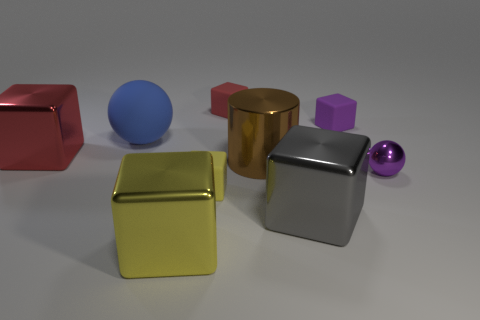What is the material of the small object that is on the left side of the purple cube and in front of the big brown cylinder?
Offer a very short reply. Rubber. What number of small objects are either gray blocks or blocks?
Your answer should be compact. 3. The purple metallic object has what size?
Give a very brief answer. Small. What is the shape of the small red object?
Your answer should be compact. Cube. Are there any other things that have the same shape as the brown thing?
Keep it short and to the point. No. Is the number of small purple matte cubes that are behind the red matte thing less than the number of big yellow shiny objects?
Offer a terse response. Yes. Do the tiny rubber thing that is to the right of the tiny red rubber object and the tiny shiny sphere have the same color?
Offer a terse response. Yes. How many rubber objects are either big cyan spheres or big brown cylinders?
Offer a very short reply. 0. The small sphere that is made of the same material as the brown object is what color?
Provide a short and direct response. Purple. What number of cylinders are shiny objects or tiny red matte things?
Make the answer very short. 1. 